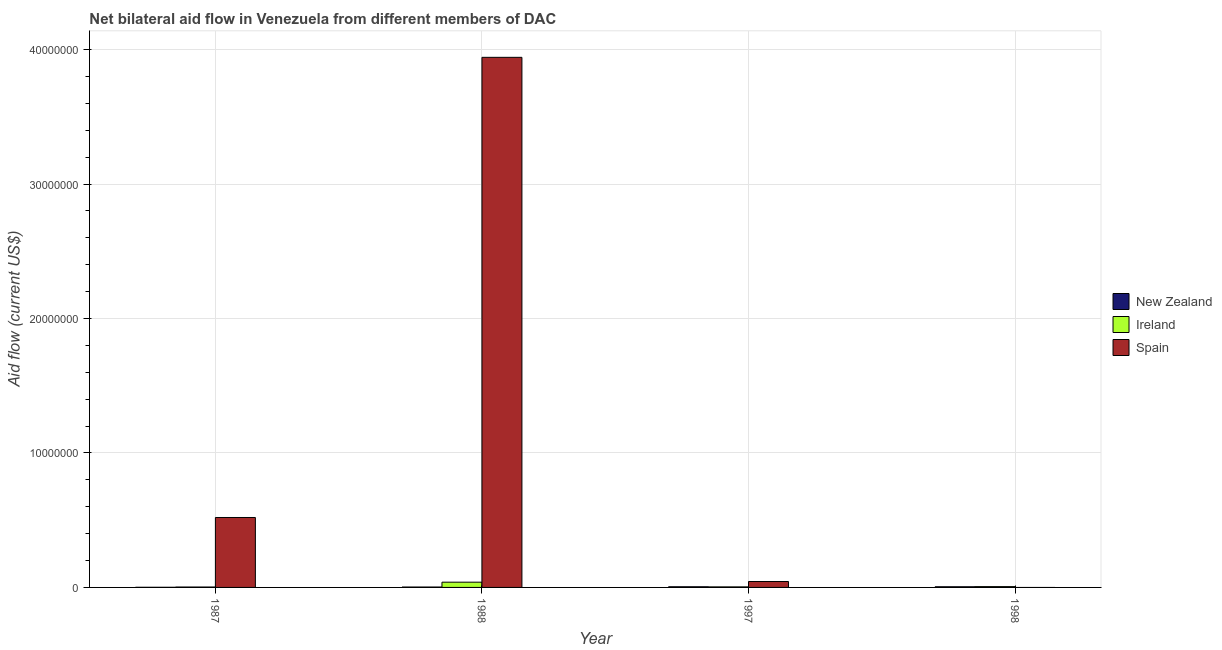How many different coloured bars are there?
Offer a very short reply. 3. Are the number of bars per tick equal to the number of legend labels?
Make the answer very short. No. How many bars are there on the 1st tick from the left?
Your answer should be compact. 3. What is the label of the 1st group of bars from the left?
Keep it short and to the point. 1987. In how many cases, is the number of bars for a given year not equal to the number of legend labels?
Keep it short and to the point. 1. What is the amount of aid provided by new zealand in 1998?
Offer a terse response. 5.00e+04. Across all years, what is the maximum amount of aid provided by new zealand?
Your answer should be very brief. 5.00e+04. Across all years, what is the minimum amount of aid provided by spain?
Your answer should be compact. 0. In which year was the amount of aid provided by new zealand maximum?
Your answer should be very brief. 1997. What is the total amount of aid provided by spain in the graph?
Provide a succinct answer. 4.51e+07. What is the difference between the amount of aid provided by spain in 1987 and that in 1997?
Provide a short and direct response. 4.76e+06. What is the difference between the amount of aid provided by spain in 1988 and the amount of aid provided by ireland in 1998?
Ensure brevity in your answer.  3.94e+07. What is the average amount of aid provided by new zealand per year?
Your response must be concise. 3.50e+04. In the year 1988, what is the difference between the amount of aid provided by ireland and amount of aid provided by new zealand?
Your answer should be very brief. 0. In how many years, is the amount of aid provided by spain greater than 24000000 US$?
Keep it short and to the point. 1. What is the ratio of the amount of aid provided by ireland in 1997 to that in 1998?
Provide a succinct answer. 0.67. Is the amount of aid provided by ireland in 1987 less than that in 1997?
Your response must be concise. Yes. What is the difference between the highest and the lowest amount of aid provided by ireland?
Give a very brief answer. 3.60e+05. Is it the case that in every year, the sum of the amount of aid provided by new zealand and amount of aid provided by ireland is greater than the amount of aid provided by spain?
Your answer should be very brief. No. How many years are there in the graph?
Ensure brevity in your answer.  4. Are the values on the major ticks of Y-axis written in scientific E-notation?
Your answer should be very brief. No. Does the graph contain any zero values?
Offer a very short reply. Yes. Does the graph contain grids?
Keep it short and to the point. Yes. How many legend labels are there?
Ensure brevity in your answer.  3. What is the title of the graph?
Ensure brevity in your answer.  Net bilateral aid flow in Venezuela from different members of DAC. Does "Ages 0-14" appear as one of the legend labels in the graph?
Keep it short and to the point. No. What is the label or title of the X-axis?
Your response must be concise. Year. What is the label or title of the Y-axis?
Provide a short and direct response. Aid flow (current US$). What is the Aid flow (current US$) in Ireland in 1987?
Provide a succinct answer. 3.00e+04. What is the Aid flow (current US$) of Spain in 1987?
Provide a short and direct response. 5.20e+06. What is the Aid flow (current US$) of New Zealand in 1988?
Ensure brevity in your answer.  3.00e+04. What is the Aid flow (current US$) of Ireland in 1988?
Make the answer very short. 3.90e+05. What is the Aid flow (current US$) in Spain in 1988?
Keep it short and to the point. 3.94e+07. What is the Aid flow (current US$) in Spain in 1997?
Your answer should be compact. 4.40e+05. What is the Aid flow (current US$) of Ireland in 1998?
Offer a terse response. 6.00e+04. What is the Aid flow (current US$) of Spain in 1998?
Provide a succinct answer. 0. Across all years, what is the maximum Aid flow (current US$) of New Zealand?
Offer a terse response. 5.00e+04. Across all years, what is the maximum Aid flow (current US$) of Ireland?
Your response must be concise. 3.90e+05. Across all years, what is the maximum Aid flow (current US$) in Spain?
Offer a very short reply. 3.94e+07. Across all years, what is the minimum Aid flow (current US$) in Spain?
Ensure brevity in your answer.  0. What is the total Aid flow (current US$) of New Zealand in the graph?
Your response must be concise. 1.40e+05. What is the total Aid flow (current US$) in Ireland in the graph?
Ensure brevity in your answer.  5.20e+05. What is the total Aid flow (current US$) in Spain in the graph?
Your response must be concise. 4.51e+07. What is the difference between the Aid flow (current US$) of New Zealand in 1987 and that in 1988?
Offer a very short reply. -2.00e+04. What is the difference between the Aid flow (current US$) in Ireland in 1987 and that in 1988?
Provide a succinct answer. -3.60e+05. What is the difference between the Aid flow (current US$) in Spain in 1987 and that in 1988?
Your answer should be very brief. -3.42e+07. What is the difference between the Aid flow (current US$) in Spain in 1987 and that in 1997?
Your answer should be very brief. 4.76e+06. What is the difference between the Aid flow (current US$) of Ireland in 1987 and that in 1998?
Your answer should be compact. -3.00e+04. What is the difference between the Aid flow (current US$) of New Zealand in 1988 and that in 1997?
Give a very brief answer. -2.00e+04. What is the difference between the Aid flow (current US$) of Ireland in 1988 and that in 1997?
Provide a short and direct response. 3.50e+05. What is the difference between the Aid flow (current US$) in Spain in 1988 and that in 1997?
Ensure brevity in your answer.  3.90e+07. What is the difference between the Aid flow (current US$) in Ireland in 1997 and that in 1998?
Make the answer very short. -2.00e+04. What is the difference between the Aid flow (current US$) of New Zealand in 1987 and the Aid flow (current US$) of Ireland in 1988?
Give a very brief answer. -3.80e+05. What is the difference between the Aid flow (current US$) of New Zealand in 1987 and the Aid flow (current US$) of Spain in 1988?
Offer a terse response. -3.94e+07. What is the difference between the Aid flow (current US$) in Ireland in 1987 and the Aid flow (current US$) in Spain in 1988?
Make the answer very short. -3.94e+07. What is the difference between the Aid flow (current US$) in New Zealand in 1987 and the Aid flow (current US$) in Spain in 1997?
Make the answer very short. -4.30e+05. What is the difference between the Aid flow (current US$) of Ireland in 1987 and the Aid flow (current US$) of Spain in 1997?
Keep it short and to the point. -4.10e+05. What is the difference between the Aid flow (current US$) in New Zealand in 1988 and the Aid flow (current US$) in Ireland in 1997?
Offer a terse response. -10000. What is the difference between the Aid flow (current US$) in New Zealand in 1988 and the Aid flow (current US$) in Spain in 1997?
Offer a very short reply. -4.10e+05. What is the difference between the Aid flow (current US$) in Ireland in 1988 and the Aid flow (current US$) in Spain in 1997?
Make the answer very short. -5.00e+04. What is the average Aid flow (current US$) of New Zealand per year?
Provide a succinct answer. 3.50e+04. What is the average Aid flow (current US$) in Spain per year?
Keep it short and to the point. 1.13e+07. In the year 1987, what is the difference between the Aid flow (current US$) in New Zealand and Aid flow (current US$) in Ireland?
Offer a terse response. -2.00e+04. In the year 1987, what is the difference between the Aid flow (current US$) in New Zealand and Aid flow (current US$) in Spain?
Your answer should be compact. -5.19e+06. In the year 1987, what is the difference between the Aid flow (current US$) of Ireland and Aid flow (current US$) of Spain?
Make the answer very short. -5.17e+06. In the year 1988, what is the difference between the Aid flow (current US$) of New Zealand and Aid flow (current US$) of Ireland?
Keep it short and to the point. -3.60e+05. In the year 1988, what is the difference between the Aid flow (current US$) in New Zealand and Aid flow (current US$) in Spain?
Offer a terse response. -3.94e+07. In the year 1988, what is the difference between the Aid flow (current US$) in Ireland and Aid flow (current US$) in Spain?
Give a very brief answer. -3.90e+07. In the year 1997, what is the difference between the Aid flow (current US$) in New Zealand and Aid flow (current US$) in Ireland?
Keep it short and to the point. 10000. In the year 1997, what is the difference between the Aid flow (current US$) of New Zealand and Aid flow (current US$) of Spain?
Keep it short and to the point. -3.90e+05. In the year 1997, what is the difference between the Aid flow (current US$) in Ireland and Aid flow (current US$) in Spain?
Offer a very short reply. -4.00e+05. In the year 1998, what is the difference between the Aid flow (current US$) in New Zealand and Aid flow (current US$) in Ireland?
Provide a short and direct response. -10000. What is the ratio of the Aid flow (current US$) of New Zealand in 1987 to that in 1988?
Ensure brevity in your answer.  0.33. What is the ratio of the Aid flow (current US$) of Ireland in 1987 to that in 1988?
Make the answer very short. 0.08. What is the ratio of the Aid flow (current US$) of Spain in 1987 to that in 1988?
Your answer should be very brief. 0.13. What is the ratio of the Aid flow (current US$) in New Zealand in 1987 to that in 1997?
Your response must be concise. 0.2. What is the ratio of the Aid flow (current US$) in Ireland in 1987 to that in 1997?
Offer a very short reply. 0.75. What is the ratio of the Aid flow (current US$) in Spain in 1987 to that in 1997?
Your answer should be compact. 11.82. What is the ratio of the Aid flow (current US$) of New Zealand in 1987 to that in 1998?
Ensure brevity in your answer.  0.2. What is the ratio of the Aid flow (current US$) in Ireland in 1987 to that in 1998?
Give a very brief answer. 0.5. What is the ratio of the Aid flow (current US$) in Ireland in 1988 to that in 1997?
Offer a terse response. 9.75. What is the ratio of the Aid flow (current US$) in Spain in 1988 to that in 1997?
Provide a succinct answer. 89.59. What is the ratio of the Aid flow (current US$) in Ireland in 1997 to that in 1998?
Your response must be concise. 0.67. What is the difference between the highest and the second highest Aid flow (current US$) of New Zealand?
Make the answer very short. 0. What is the difference between the highest and the second highest Aid flow (current US$) of Spain?
Provide a short and direct response. 3.42e+07. What is the difference between the highest and the lowest Aid flow (current US$) in Ireland?
Offer a terse response. 3.60e+05. What is the difference between the highest and the lowest Aid flow (current US$) in Spain?
Your answer should be compact. 3.94e+07. 